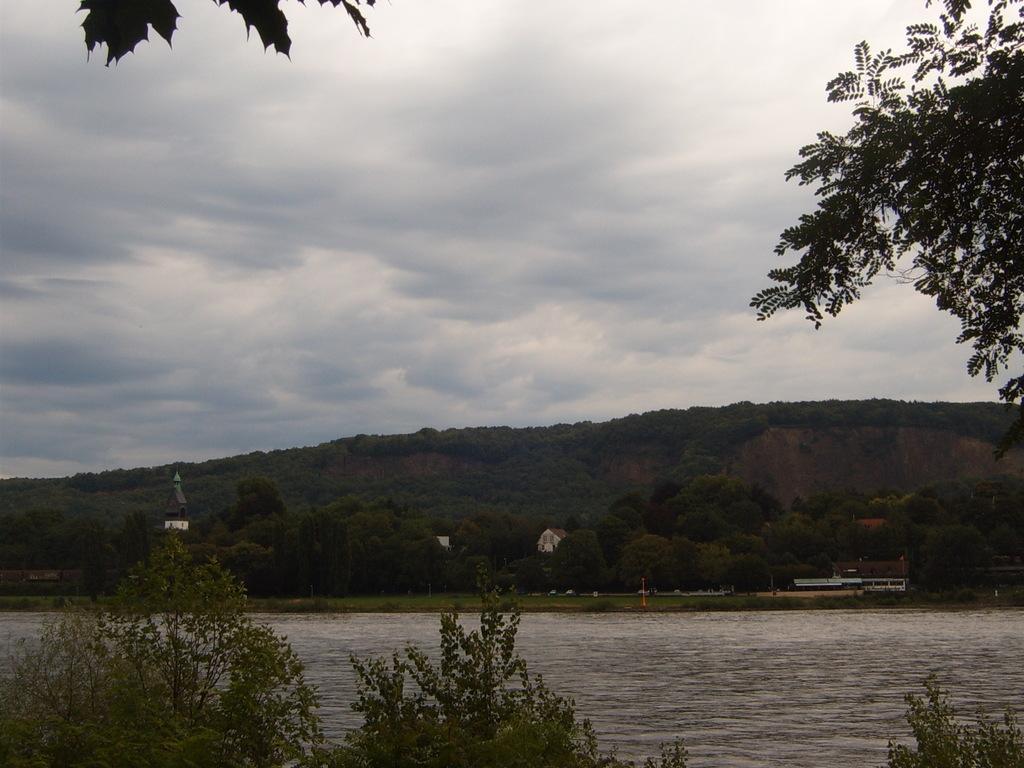Can you describe this image briefly? In this image I can see water, number of trees, cloudy sky and I can see few buildings in background. 